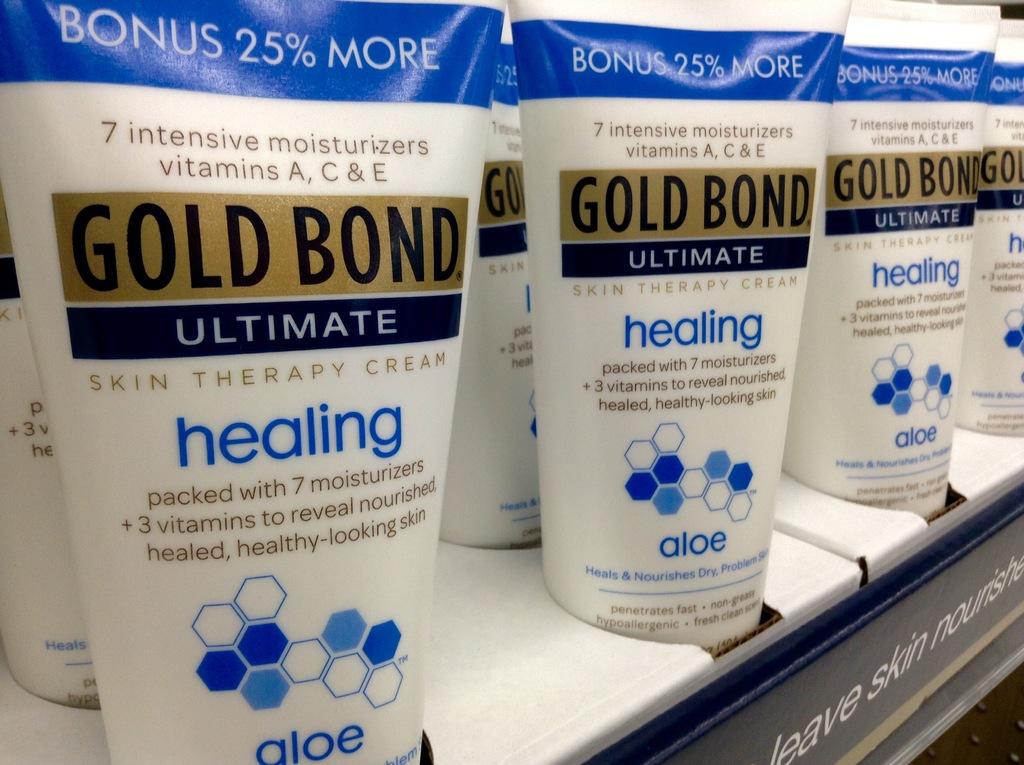What brand is on the shelf?
Make the answer very short. Gold bond. 